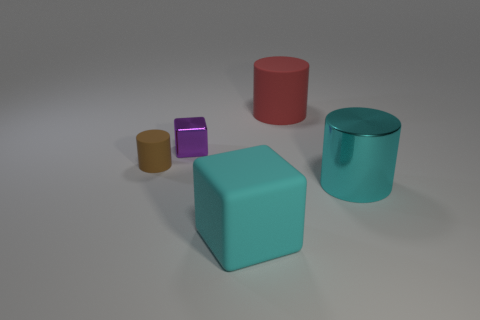Subtract all tiny brown matte cylinders. How many cylinders are left? 2 Add 2 large cyan shiny cylinders. How many objects exist? 7 Subtract 1 cubes. How many cubes are left? 1 Subtract all brown cylinders. How many cylinders are left? 2 Subtract all cylinders. How many objects are left? 2 Subtract all big red matte objects. Subtract all large objects. How many objects are left? 1 Add 5 matte cylinders. How many matte cylinders are left? 7 Add 3 red rubber cylinders. How many red rubber cylinders exist? 4 Subtract 0 gray balls. How many objects are left? 5 Subtract all gray cylinders. Subtract all yellow balls. How many cylinders are left? 3 